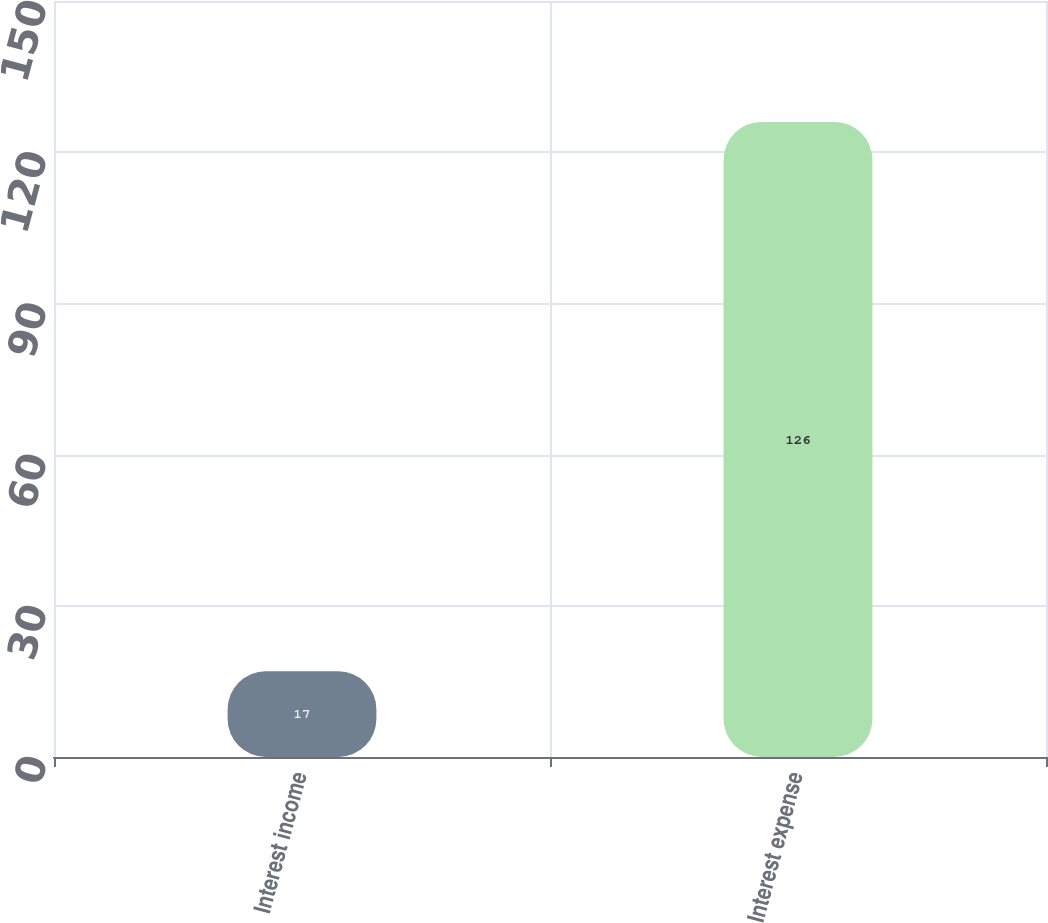Convert chart. <chart><loc_0><loc_0><loc_500><loc_500><bar_chart><fcel>Interest income<fcel>Interest expense<nl><fcel>17<fcel>126<nl></chart> 